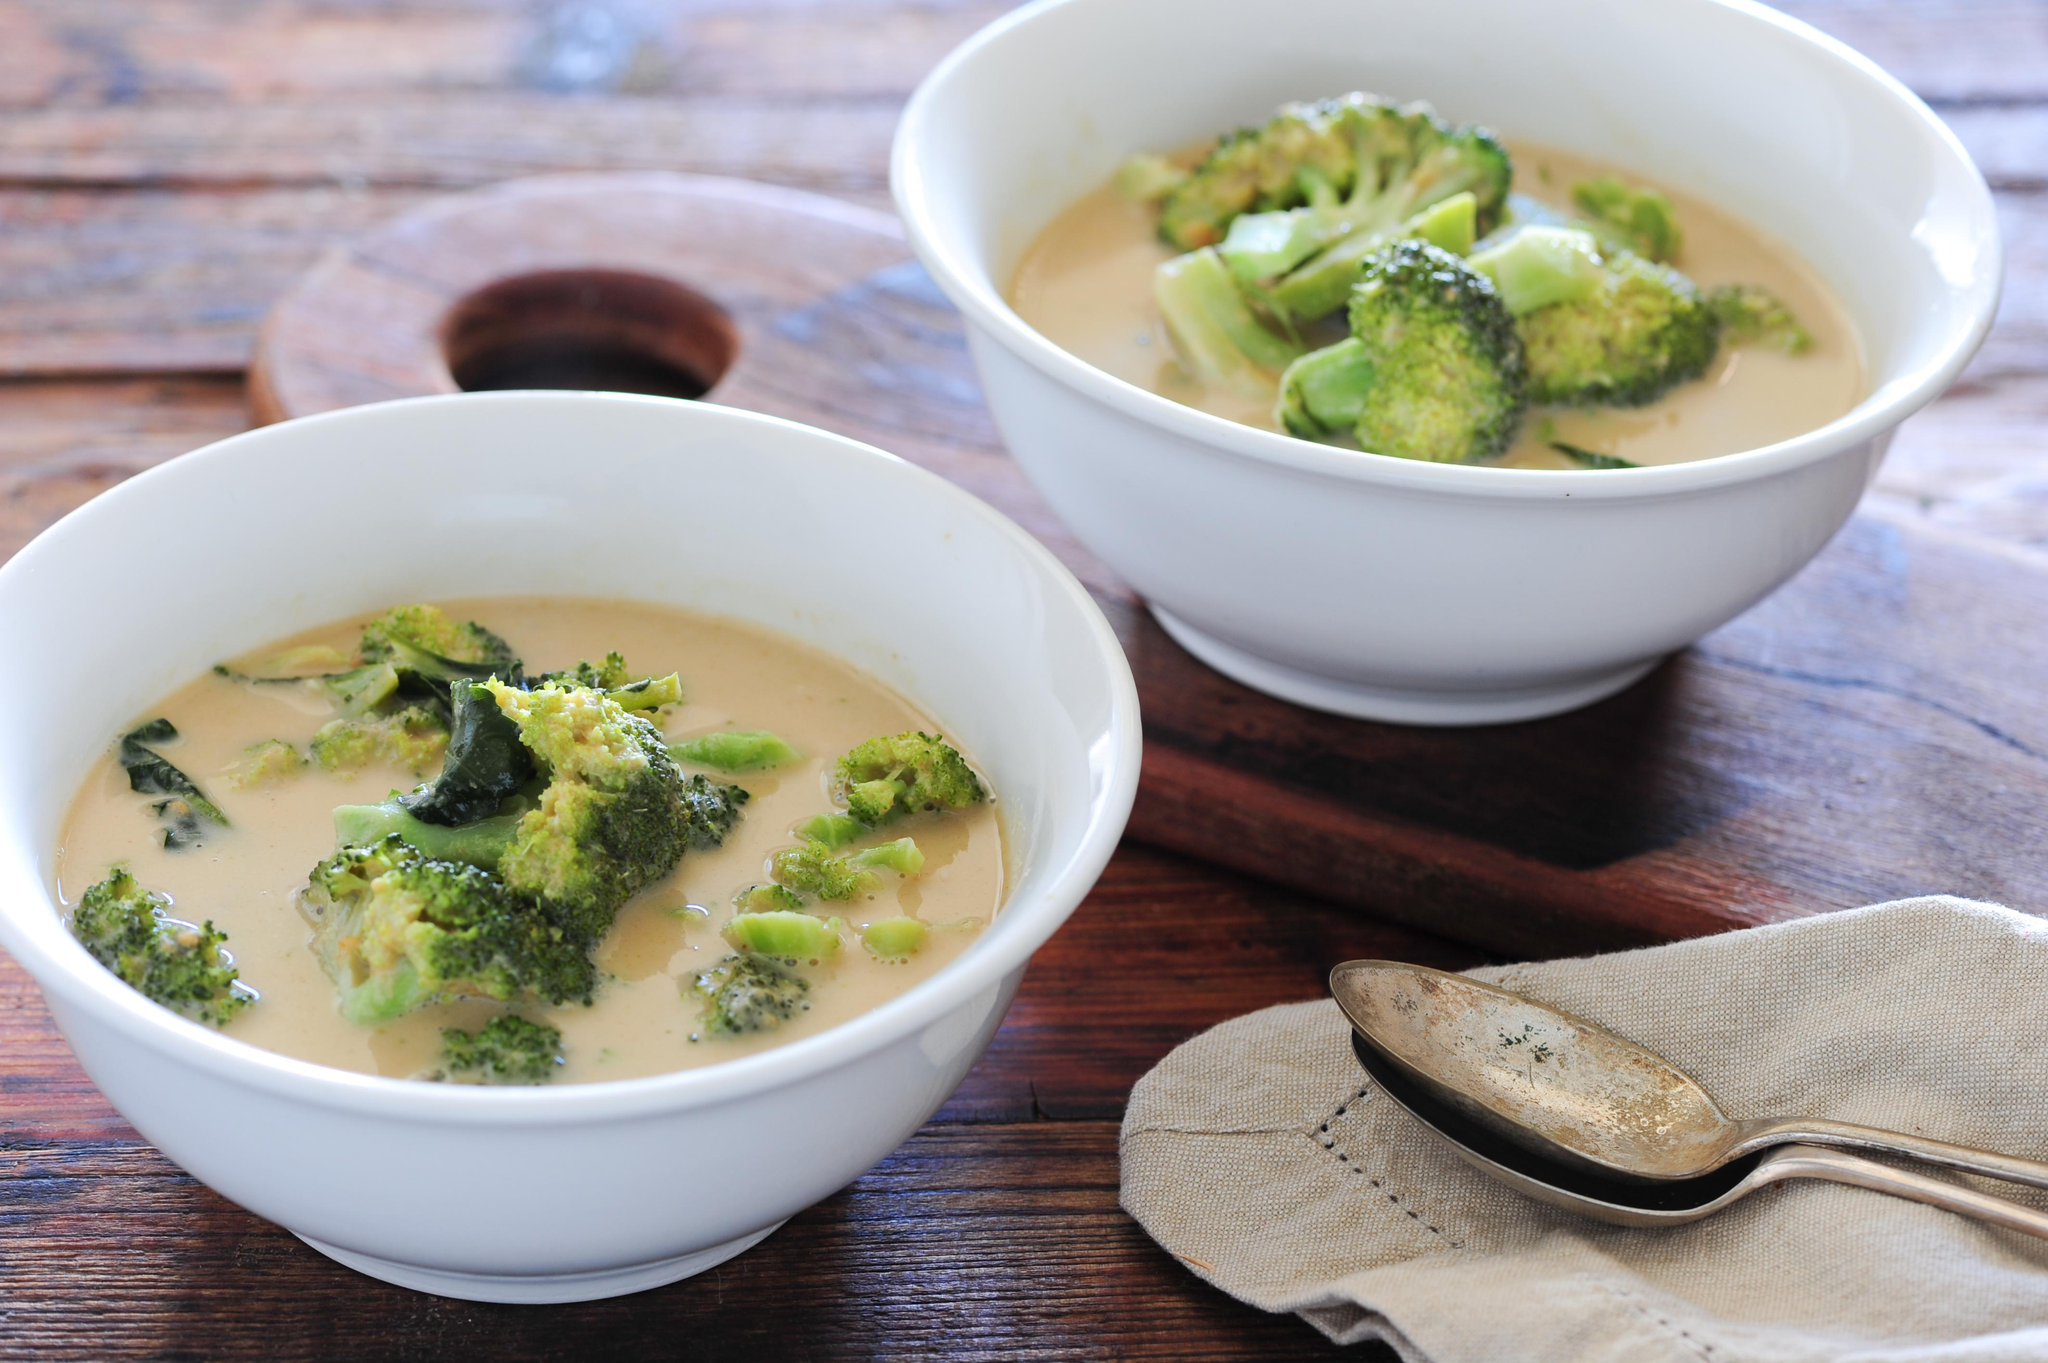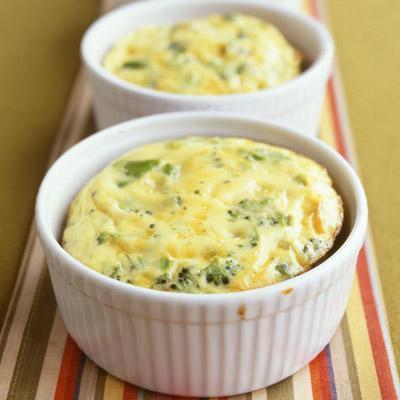The first image is the image on the left, the second image is the image on the right. Given the left and right images, does the statement "There is a white plate beneath the soup in the image on the left." hold true? Answer yes or no. No. 